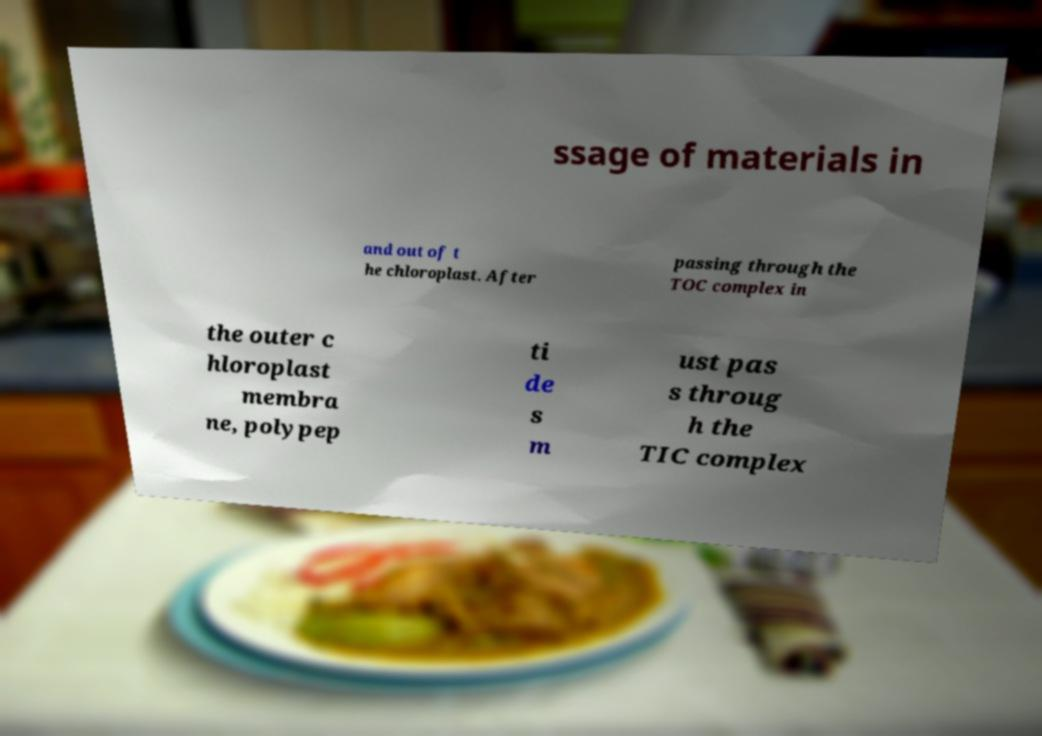Please identify and transcribe the text found in this image. ssage of materials in and out of t he chloroplast. After passing through the TOC complex in the outer c hloroplast membra ne, polypep ti de s m ust pas s throug h the TIC complex 